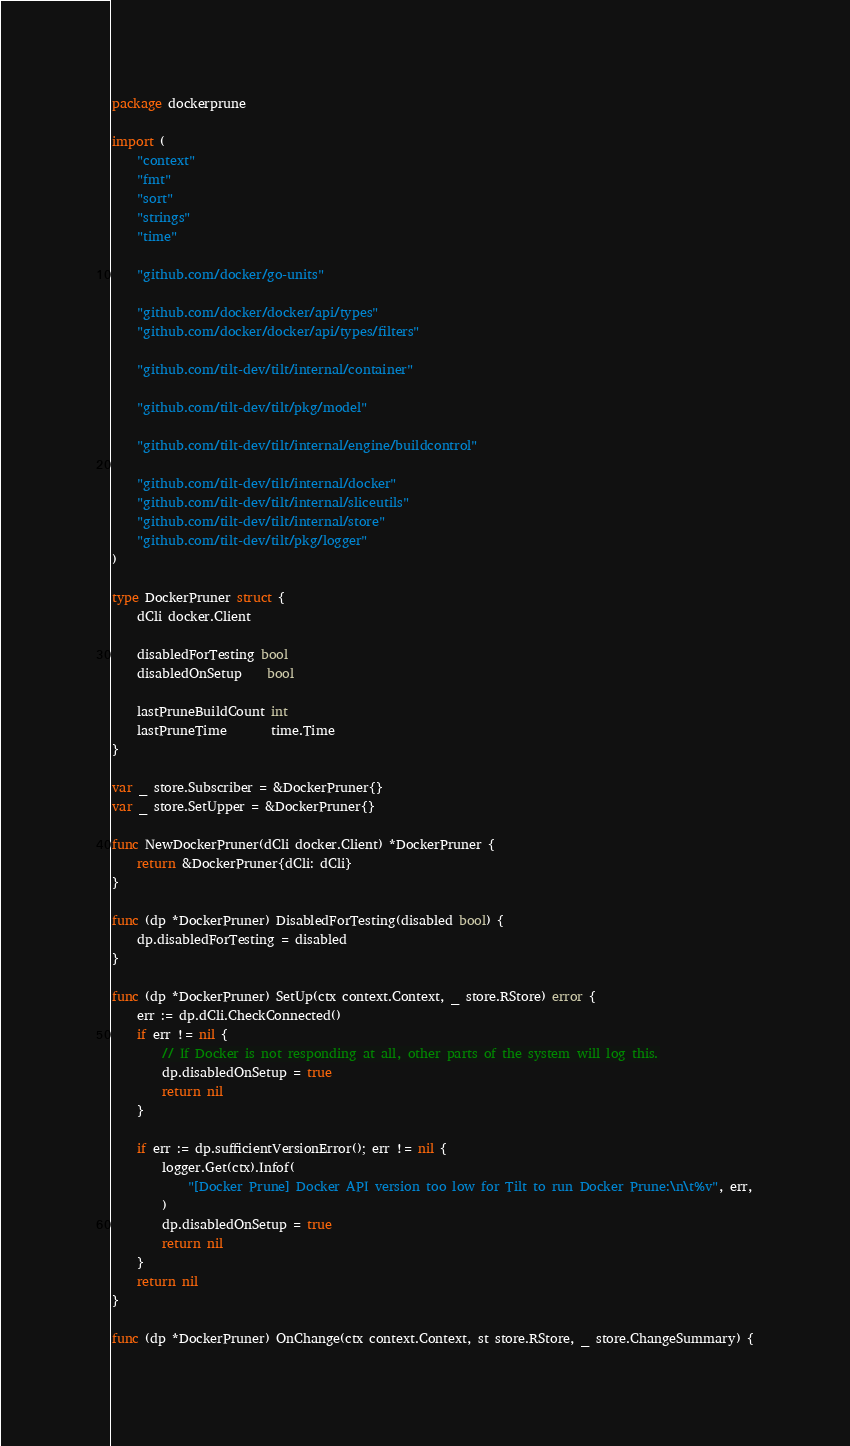Convert code to text. <code><loc_0><loc_0><loc_500><loc_500><_Go_>package dockerprune

import (
	"context"
	"fmt"
	"sort"
	"strings"
	"time"

	"github.com/docker/go-units"

	"github.com/docker/docker/api/types"
	"github.com/docker/docker/api/types/filters"

	"github.com/tilt-dev/tilt/internal/container"

	"github.com/tilt-dev/tilt/pkg/model"

	"github.com/tilt-dev/tilt/internal/engine/buildcontrol"

	"github.com/tilt-dev/tilt/internal/docker"
	"github.com/tilt-dev/tilt/internal/sliceutils"
	"github.com/tilt-dev/tilt/internal/store"
	"github.com/tilt-dev/tilt/pkg/logger"
)

type DockerPruner struct {
	dCli docker.Client

	disabledForTesting bool
	disabledOnSetup    bool

	lastPruneBuildCount int
	lastPruneTime       time.Time
}

var _ store.Subscriber = &DockerPruner{}
var _ store.SetUpper = &DockerPruner{}

func NewDockerPruner(dCli docker.Client) *DockerPruner {
	return &DockerPruner{dCli: dCli}
}

func (dp *DockerPruner) DisabledForTesting(disabled bool) {
	dp.disabledForTesting = disabled
}

func (dp *DockerPruner) SetUp(ctx context.Context, _ store.RStore) error {
	err := dp.dCli.CheckConnected()
	if err != nil {
		// If Docker is not responding at all, other parts of the system will log this.
		dp.disabledOnSetup = true
		return nil
	}

	if err := dp.sufficientVersionError(); err != nil {
		logger.Get(ctx).Infof(
			"[Docker Prune] Docker API version too low for Tilt to run Docker Prune:\n\t%v", err,
		)
		dp.disabledOnSetup = true
		return nil
	}
	return nil
}

func (dp *DockerPruner) OnChange(ctx context.Context, st store.RStore, _ store.ChangeSummary) {</code> 